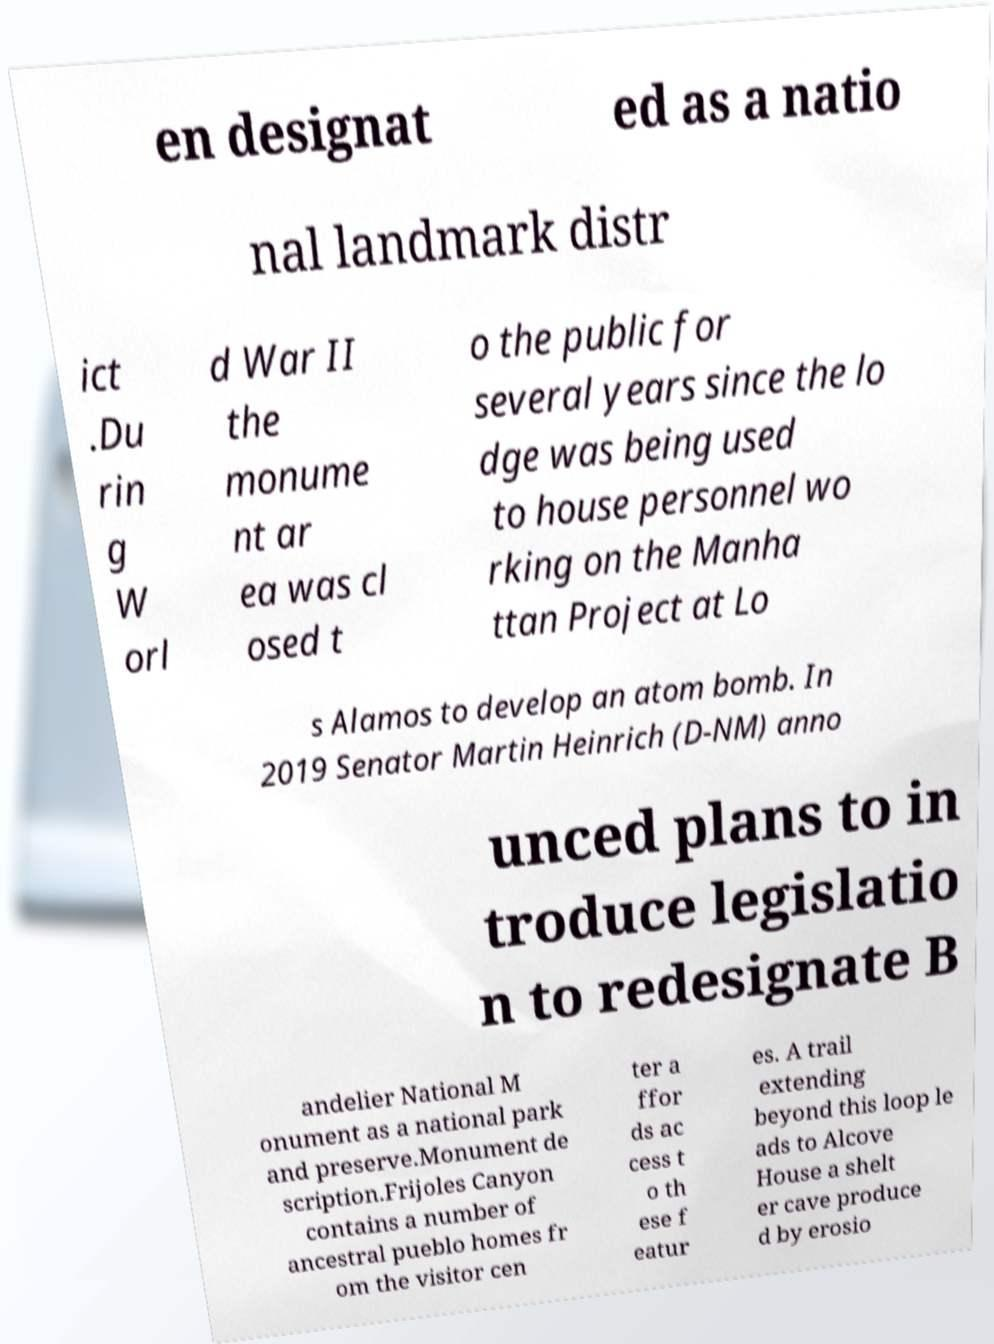Please read and relay the text visible in this image. What does it say? en designat ed as a natio nal landmark distr ict .Du rin g W orl d War II the monume nt ar ea was cl osed t o the public for several years since the lo dge was being used to house personnel wo rking on the Manha ttan Project at Lo s Alamos to develop an atom bomb. In 2019 Senator Martin Heinrich (D-NM) anno unced plans to in troduce legislatio n to redesignate B andelier National M onument as a national park and preserve.Monument de scription.Frijoles Canyon contains a number of ancestral pueblo homes fr om the visitor cen ter a ffor ds ac cess t o th ese f eatur es. A trail extending beyond this loop le ads to Alcove House a shelt er cave produce d by erosio 